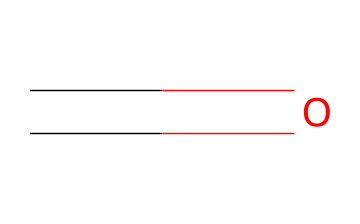What is the molecular formula of this compound? The SMILES representation denotes a carbon atom (C) double-bonded to an oxygen atom (O). Therefore, the molecule consists of one carbon and one oxygen, leading to the molecular formula of H2CO.
Answer: H2CO How many total atoms are present in formaldehyde? The molecular formula H2CO indicates there are three different types of atoms: 1 carbon, 1 oxygen, and 2 hydrogens. Adding these gives a total of 1 + 1 + 2 = 4 atoms.
Answer: 4 atoms What type of bond is present between the carbon and oxygen in formaldehyde? The SMILES representation shows a double bond between C and O, which means the carbon and oxygen share two pairs of electrons. This is characteristic of a double bond.
Answer: double bond What is the oxidation state of carbon in formaldehyde? In formaldehyde (H2CO), carbon is bonded to two hydrogen and one oxygen atom. The oxidation state can be calculated by considering hydrogen as +1 each and oxygen as -2, resulting in carbon's oxidation state being determined to be +1.
Answer: +1 Is formaldehyde considered a toxic chemical? Formaldehyde is recognized as a toxic substance, often cited for its presence in indoor air pollution, where it can adversely affect health. This classification is based on its chemical properties and effects on humans.
Answer: Yes What are common sources of formaldehyde indoors? Common indoor sources include furniture, pressed wood products, household cleaners, and smoking. These materials and actions release formaldehyde vapors into the air, contributing to indoor air pollution.
Answer: Furniture, pressed wood products How does formaldehyde affect human health? Exposure to formaldehyde can lead to various health issues, including respiratory problems, skin irritation, and it is classified as a probable human carcinogen. Therefore, understanding its effects is crucial for safety.
Answer: Respiratory problems, skin irritation 